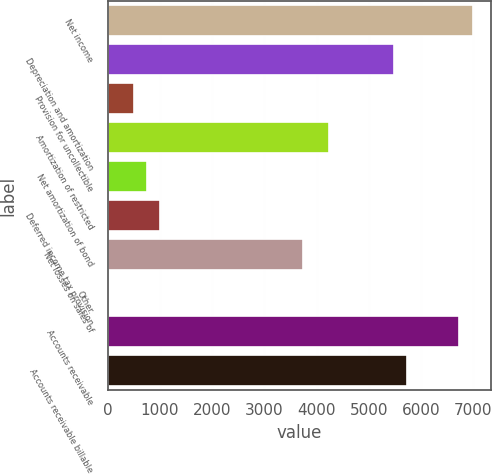<chart> <loc_0><loc_0><loc_500><loc_500><bar_chart><fcel>Net income<fcel>Depreciation and amortization<fcel>Provision for uncollectible<fcel>Amortization of restricted<fcel>Net amortization of bond<fcel>Deferred income tax provision<fcel>Net losses on sales of<fcel>Other<fcel>Accounts receivable<fcel>Accounts receivable billable<nl><fcel>6981.6<fcel>5485.8<fcel>499.8<fcel>4239.3<fcel>749.1<fcel>998.4<fcel>3740.7<fcel>1.2<fcel>6732.3<fcel>5735.1<nl></chart> 